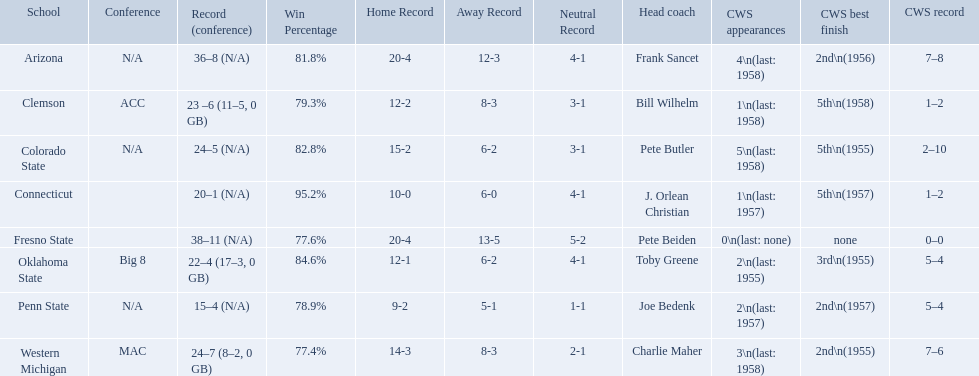What were scores for each school in the 1959 ncaa tournament? 36–8 (N/A), 23 –6 (11–5, 0 GB), 24–5 (N/A), 20–1 (N/A), 38–11 (N/A), 22–4 (17–3, 0 GB), 15–4 (N/A), 24–7 (8–2, 0 GB). What score did not have at least 16 wins? 15–4 (N/A). What team earned this score? Penn State. What are all the schools? Arizona, Clemson, Colorado State, Connecticut, Fresno State, Oklahoma State, Penn State, Western Michigan. Which are clemson and western michigan? Clemson, Western Michigan. Of these, which has more cws appearances? Western Michigan. 